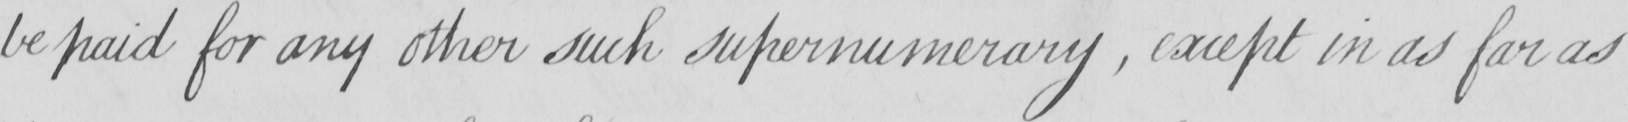What does this handwritten line say? be paid for any other such supernumerary , except in as far as 